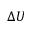<formula> <loc_0><loc_0><loc_500><loc_500>\Delta U</formula> 